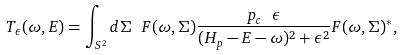<formula> <loc_0><loc_0><loc_500><loc_500>T _ { \epsilon } ( \omega , E ) = \int _ { S ^ { 2 } } d \Sigma \ F ( \omega , \Sigma ) \frac { p _ { c } \ \epsilon } { ( H _ { p } - E - \omega ) ^ { 2 } + \epsilon ^ { 2 } } F ( \omega , \Sigma ) ^ { * } ,</formula> 